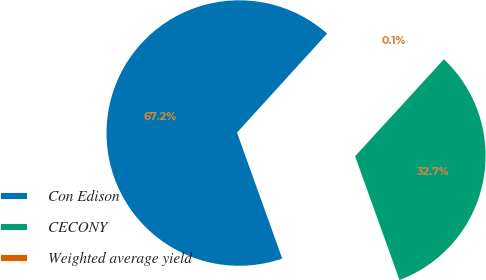Convert chart. <chart><loc_0><loc_0><loc_500><loc_500><pie_chart><fcel>Con Edison<fcel>CECONY<fcel>Weighted average yield<nl><fcel>67.23%<fcel>32.71%<fcel>0.05%<nl></chart> 